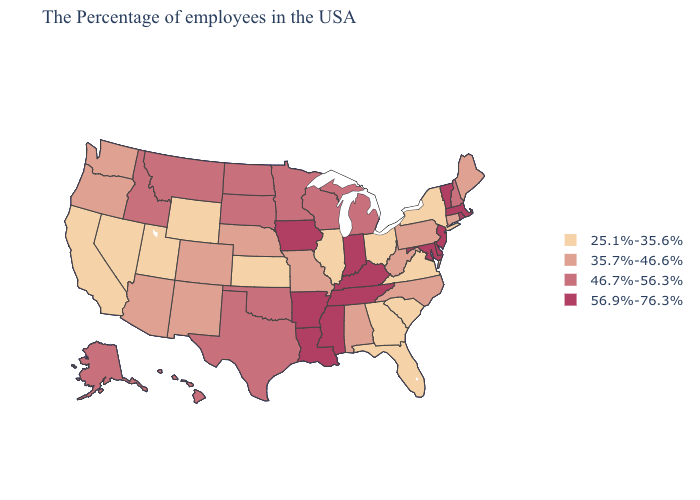What is the value of Vermont?
Short answer required. 56.9%-76.3%. What is the value of Nebraska?
Concise answer only. 35.7%-46.6%. Does Kentucky have the highest value in the South?
Quick response, please. Yes. Does Alaska have the lowest value in the West?
Write a very short answer. No. Which states have the highest value in the USA?
Concise answer only. Massachusetts, Rhode Island, Vermont, New Jersey, Delaware, Maryland, Kentucky, Indiana, Tennessee, Mississippi, Louisiana, Arkansas, Iowa. Name the states that have a value in the range 25.1%-35.6%?
Quick response, please. New York, Virginia, South Carolina, Ohio, Florida, Georgia, Illinois, Kansas, Wyoming, Utah, Nevada, California. Does Virginia have the lowest value in the USA?
Answer briefly. Yes. Among the states that border Rhode Island , which have the highest value?
Write a very short answer. Massachusetts. Among the states that border Louisiana , which have the lowest value?
Be succinct. Texas. Does Arkansas have the highest value in the USA?
Give a very brief answer. Yes. Name the states that have a value in the range 56.9%-76.3%?
Be succinct. Massachusetts, Rhode Island, Vermont, New Jersey, Delaware, Maryland, Kentucky, Indiana, Tennessee, Mississippi, Louisiana, Arkansas, Iowa. Name the states that have a value in the range 25.1%-35.6%?
Quick response, please. New York, Virginia, South Carolina, Ohio, Florida, Georgia, Illinois, Kansas, Wyoming, Utah, Nevada, California. Which states hav the highest value in the South?
Concise answer only. Delaware, Maryland, Kentucky, Tennessee, Mississippi, Louisiana, Arkansas. Does the first symbol in the legend represent the smallest category?
Give a very brief answer. Yes. Among the states that border Minnesota , which have the highest value?
Give a very brief answer. Iowa. 